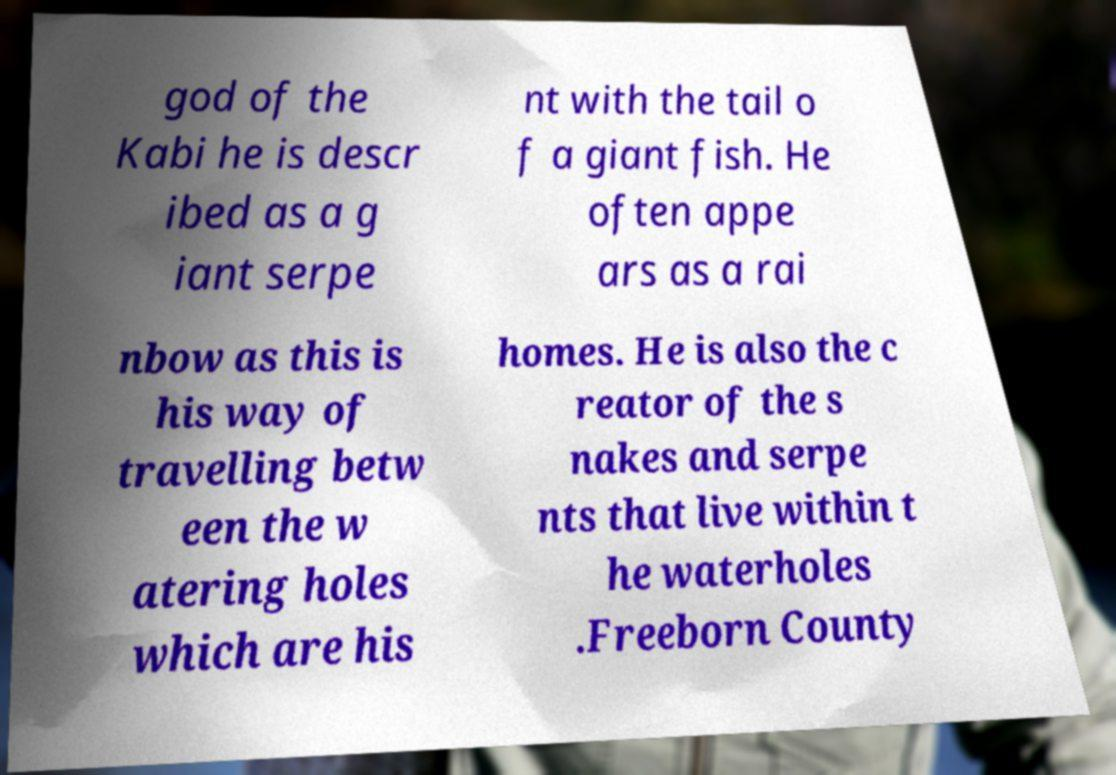Can you accurately transcribe the text from the provided image for me? god of the Kabi he is descr ibed as a g iant serpe nt with the tail o f a giant fish. He often appe ars as a rai nbow as this is his way of travelling betw een the w atering holes which are his homes. He is also the c reator of the s nakes and serpe nts that live within t he waterholes .Freeborn County 